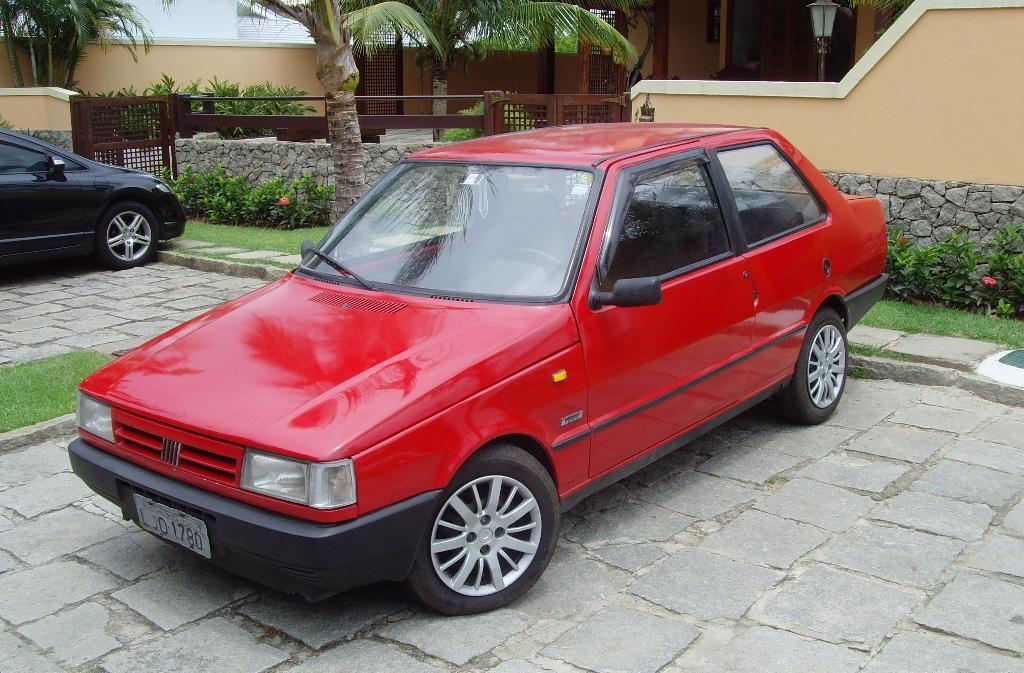What is the main subject in the center of the image? There are cars in the center of the image. What can be seen in the background of the image? There is a building and trees in the background of the image. What is the purpose of the fence in the image? The fence in the image serves as a barrier or boundary. Can you hear the grape laughing in the image? There is no grape present in the image, and therefore it cannot be heard laughing. 